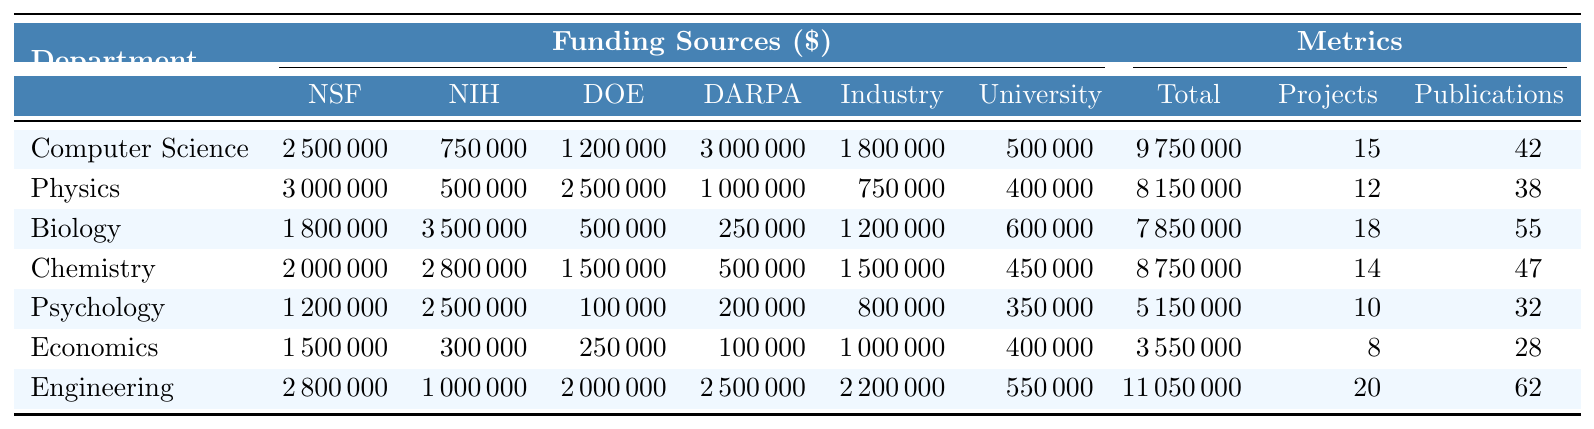What is the total funding for the Biology department? From the table, the total funding for the Biology department is listed as 7,850,000.
Answer: 7,850,000 Which department received the highest amount of funding from Industry Partners? The table indicates that the Engineering department received 2,200,000 from Industry Partners, which is the highest among all departments.
Answer: Engineering How many projects were funded in total across all departments? By summing the "Projects Funded" column (15 + 12 + 18 + 14 + 10 + 8 + 20 = 97), the total number of funded projects across all departments is 97.
Answer: 97 What is the total funding received by the Engineering department from NSF? According to the table, the Engineering department received 2,800,000 from NSF.
Answer: 2,800,000 True or False: The Psychology department received more funding from NIH than from NSF. The table shows that the Psychology department received 2,500,000 from NIH and 1,200,000 from NSF. Therefore, the statement is true.
Answer: True Which department has the most publications relative to the number of projects funded? The publication per project is calculated for each department: Computer Science (42/15), Physics (38/12), Biology (55/18), Chemistry (47/14), Psychology (32/10), Economics (28/8), Engineering (62/20). The Biology department has the highest ratio of approximately 3.06.
Answer: Biology What is the difference in total funding between the Computer Science and Physics departments? The total funding for Computer Science is 9,750,000 and for Physics it is 8,150,000. The difference is calculated as 9,750,000 - 8,150,000 = 1,600,000.
Answer: 1,600,000 Which funding source contributed the least to the Economics department? From the table, the smallest contribution to the Economics department is from the NIH, with a funding amount of 300,000.
Answer: NIH If we average the publications across all departments, what is the result? By summing the publications (42 + 38 + 55 + 47 + 32 + 28 + 62 = 304) and dividing by the total number of departments (7), the average publications come out to 304 / 7 ≈ 43.43.
Answer: 43.43 Which department received the most overall funding? A glance at the "Total Funding" column shows that the Engineering department received the highest overall funding amount of 11,050,000.
Answer: Engineering 